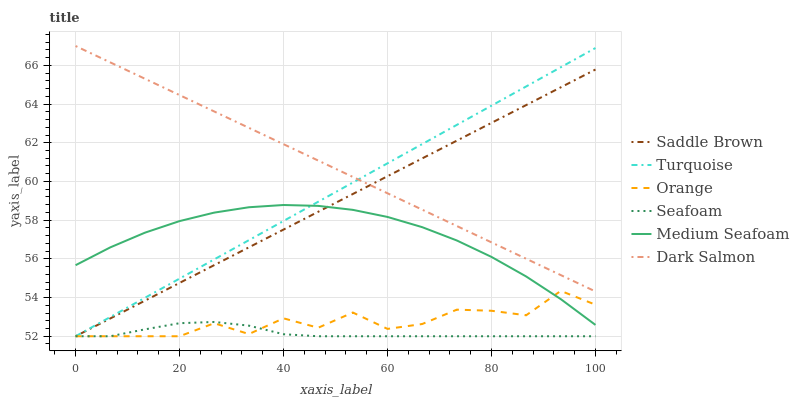Does Seafoam have the minimum area under the curve?
Answer yes or no. Yes. Does Dark Salmon have the maximum area under the curve?
Answer yes or no. Yes. Does Dark Salmon have the minimum area under the curve?
Answer yes or no. No. Does Seafoam have the maximum area under the curve?
Answer yes or no. No. Is Turquoise the smoothest?
Answer yes or no. Yes. Is Orange the roughest?
Answer yes or no. Yes. Is Seafoam the smoothest?
Answer yes or no. No. Is Seafoam the roughest?
Answer yes or no. No. Does Turquoise have the lowest value?
Answer yes or no. Yes. Does Dark Salmon have the lowest value?
Answer yes or no. No. Does Dark Salmon have the highest value?
Answer yes or no. Yes. Does Seafoam have the highest value?
Answer yes or no. No. Is Seafoam less than Dark Salmon?
Answer yes or no. Yes. Is Dark Salmon greater than Orange?
Answer yes or no. Yes. Does Dark Salmon intersect Saddle Brown?
Answer yes or no. Yes. Is Dark Salmon less than Saddle Brown?
Answer yes or no. No. Is Dark Salmon greater than Saddle Brown?
Answer yes or no. No. Does Seafoam intersect Dark Salmon?
Answer yes or no. No. 